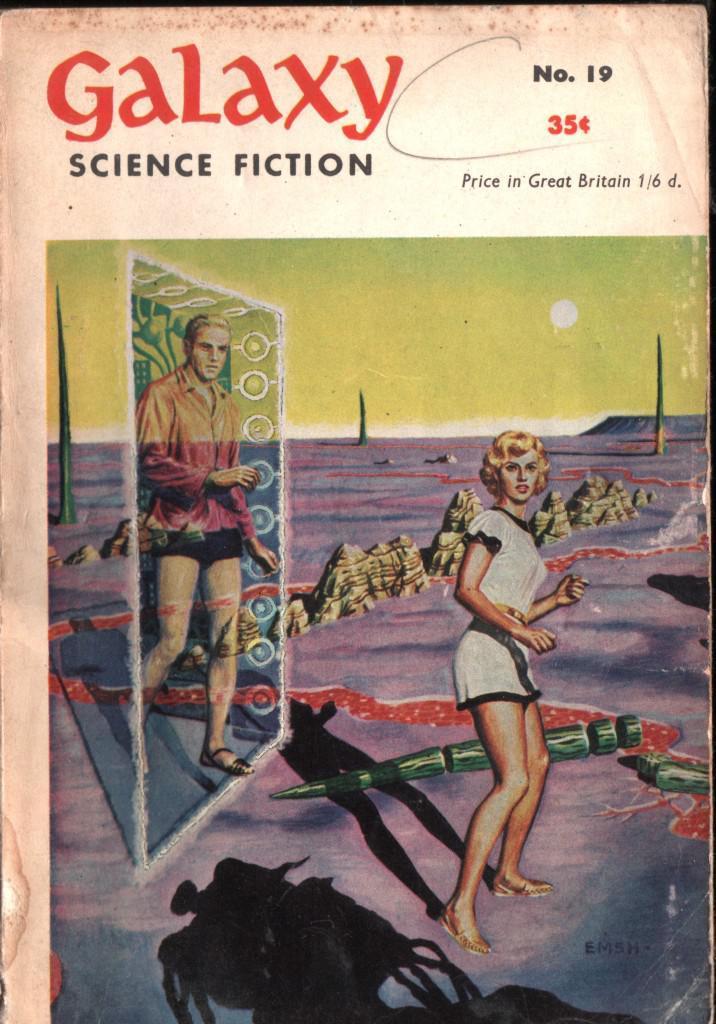Describe this image in one or two sentences. In this picture I can see a cartoon image of a man, woman, sun and the sky. Here I can see something written on the image. 